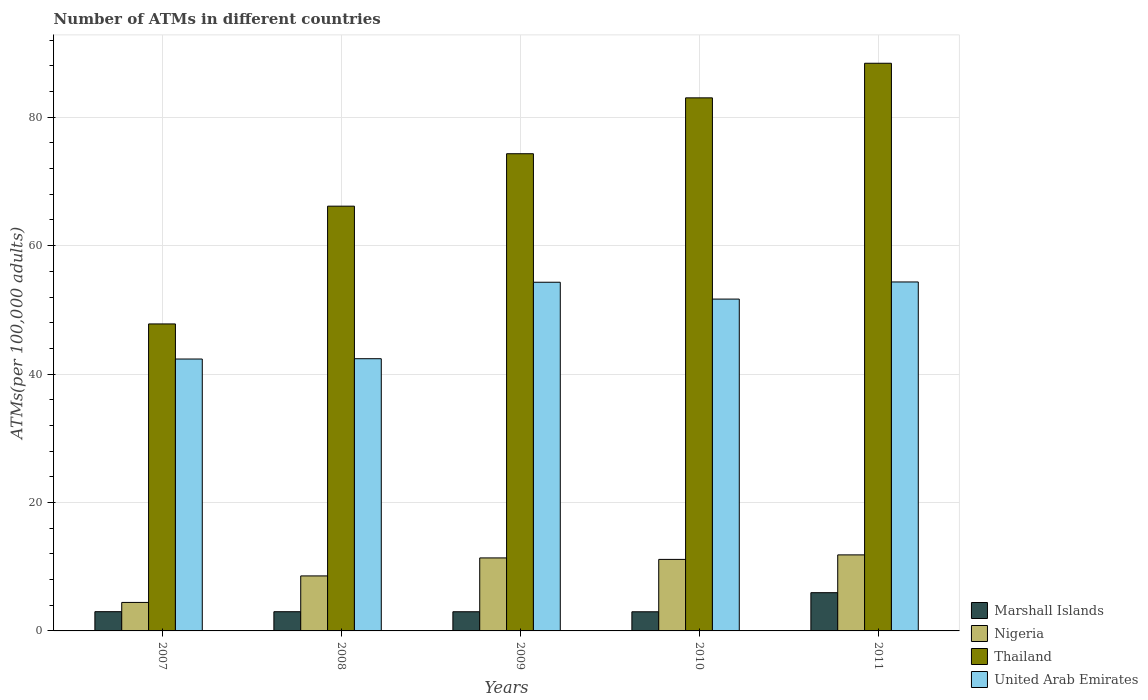How many different coloured bars are there?
Make the answer very short. 4. Are the number of bars per tick equal to the number of legend labels?
Offer a terse response. Yes. What is the label of the 2nd group of bars from the left?
Ensure brevity in your answer.  2008. What is the number of ATMs in Marshall Islands in 2009?
Offer a very short reply. 2.99. Across all years, what is the maximum number of ATMs in United Arab Emirates?
Your response must be concise. 54.35. Across all years, what is the minimum number of ATMs in Thailand?
Make the answer very short. 47.81. What is the total number of ATMs in Thailand in the graph?
Keep it short and to the point. 359.71. What is the difference between the number of ATMs in United Arab Emirates in 2007 and that in 2009?
Offer a terse response. -11.96. What is the difference between the number of ATMs in Marshall Islands in 2008 and the number of ATMs in Thailand in 2009?
Offer a very short reply. -71.33. What is the average number of ATMs in Nigeria per year?
Make the answer very short. 9.47. In the year 2009, what is the difference between the number of ATMs in Nigeria and number of ATMs in Marshall Islands?
Keep it short and to the point. 8.38. In how many years, is the number of ATMs in Nigeria greater than 40?
Offer a very short reply. 0. What is the ratio of the number of ATMs in Thailand in 2010 to that in 2011?
Your answer should be compact. 0.94. What is the difference between the highest and the second highest number of ATMs in Thailand?
Give a very brief answer. 5.39. What is the difference between the highest and the lowest number of ATMs in United Arab Emirates?
Make the answer very short. 12. Is it the case that in every year, the sum of the number of ATMs in Marshall Islands and number of ATMs in Nigeria is greater than the sum of number of ATMs in United Arab Emirates and number of ATMs in Thailand?
Keep it short and to the point. Yes. What does the 1st bar from the left in 2008 represents?
Your answer should be very brief. Marshall Islands. What does the 4th bar from the right in 2007 represents?
Your answer should be compact. Marshall Islands. How many bars are there?
Make the answer very short. 20. How many years are there in the graph?
Make the answer very short. 5. What is the difference between two consecutive major ticks on the Y-axis?
Provide a short and direct response. 20. Are the values on the major ticks of Y-axis written in scientific E-notation?
Ensure brevity in your answer.  No. Does the graph contain any zero values?
Offer a very short reply. No. How many legend labels are there?
Provide a succinct answer. 4. How are the legend labels stacked?
Your response must be concise. Vertical. What is the title of the graph?
Give a very brief answer. Number of ATMs in different countries. Does "Bermuda" appear as one of the legend labels in the graph?
Offer a terse response. No. What is the label or title of the Y-axis?
Provide a succinct answer. ATMs(per 100,0 adults). What is the ATMs(per 100,000 adults) in Marshall Islands in 2007?
Offer a terse response. 3. What is the ATMs(per 100,000 adults) in Nigeria in 2007?
Provide a short and direct response. 4.44. What is the ATMs(per 100,000 adults) of Thailand in 2007?
Your answer should be very brief. 47.81. What is the ATMs(per 100,000 adults) in United Arab Emirates in 2007?
Ensure brevity in your answer.  42.34. What is the ATMs(per 100,000 adults) of Marshall Islands in 2008?
Give a very brief answer. 2.99. What is the ATMs(per 100,000 adults) in Nigeria in 2008?
Your answer should be compact. 8.57. What is the ATMs(per 100,000 adults) in Thailand in 2008?
Your answer should be very brief. 66.15. What is the ATMs(per 100,000 adults) of United Arab Emirates in 2008?
Make the answer very short. 42.39. What is the ATMs(per 100,000 adults) in Marshall Islands in 2009?
Offer a very short reply. 2.99. What is the ATMs(per 100,000 adults) of Nigeria in 2009?
Your response must be concise. 11.37. What is the ATMs(per 100,000 adults) in Thailand in 2009?
Your response must be concise. 74.32. What is the ATMs(per 100,000 adults) of United Arab Emirates in 2009?
Your answer should be very brief. 54.3. What is the ATMs(per 100,000 adults) in Marshall Islands in 2010?
Your answer should be compact. 2.98. What is the ATMs(per 100,000 adults) in Nigeria in 2010?
Your response must be concise. 11.14. What is the ATMs(per 100,000 adults) of Thailand in 2010?
Your answer should be very brief. 83.02. What is the ATMs(per 100,000 adults) in United Arab Emirates in 2010?
Offer a terse response. 51.68. What is the ATMs(per 100,000 adults) of Marshall Islands in 2011?
Provide a succinct answer. 5.95. What is the ATMs(per 100,000 adults) of Nigeria in 2011?
Keep it short and to the point. 11.84. What is the ATMs(per 100,000 adults) of Thailand in 2011?
Provide a short and direct response. 88.41. What is the ATMs(per 100,000 adults) of United Arab Emirates in 2011?
Your answer should be compact. 54.35. Across all years, what is the maximum ATMs(per 100,000 adults) in Marshall Islands?
Provide a short and direct response. 5.95. Across all years, what is the maximum ATMs(per 100,000 adults) of Nigeria?
Keep it short and to the point. 11.84. Across all years, what is the maximum ATMs(per 100,000 adults) in Thailand?
Offer a very short reply. 88.41. Across all years, what is the maximum ATMs(per 100,000 adults) in United Arab Emirates?
Give a very brief answer. 54.35. Across all years, what is the minimum ATMs(per 100,000 adults) of Marshall Islands?
Offer a terse response. 2.98. Across all years, what is the minimum ATMs(per 100,000 adults) of Nigeria?
Make the answer very short. 4.44. Across all years, what is the minimum ATMs(per 100,000 adults) of Thailand?
Ensure brevity in your answer.  47.81. Across all years, what is the minimum ATMs(per 100,000 adults) in United Arab Emirates?
Ensure brevity in your answer.  42.34. What is the total ATMs(per 100,000 adults) of Marshall Islands in the graph?
Offer a terse response. 17.91. What is the total ATMs(per 100,000 adults) of Nigeria in the graph?
Provide a short and direct response. 47.36. What is the total ATMs(per 100,000 adults) of Thailand in the graph?
Give a very brief answer. 359.71. What is the total ATMs(per 100,000 adults) in United Arab Emirates in the graph?
Your response must be concise. 245.07. What is the difference between the ATMs(per 100,000 adults) in Marshall Islands in 2007 and that in 2008?
Provide a succinct answer. 0.01. What is the difference between the ATMs(per 100,000 adults) in Nigeria in 2007 and that in 2008?
Make the answer very short. -4.13. What is the difference between the ATMs(per 100,000 adults) of Thailand in 2007 and that in 2008?
Keep it short and to the point. -18.34. What is the difference between the ATMs(per 100,000 adults) of United Arab Emirates in 2007 and that in 2008?
Provide a short and direct response. -0.05. What is the difference between the ATMs(per 100,000 adults) in Marshall Islands in 2007 and that in 2009?
Provide a short and direct response. 0.01. What is the difference between the ATMs(per 100,000 adults) in Nigeria in 2007 and that in 2009?
Offer a terse response. -6.93. What is the difference between the ATMs(per 100,000 adults) in Thailand in 2007 and that in 2009?
Make the answer very short. -26.51. What is the difference between the ATMs(per 100,000 adults) of United Arab Emirates in 2007 and that in 2009?
Your answer should be very brief. -11.96. What is the difference between the ATMs(per 100,000 adults) in Marshall Islands in 2007 and that in 2010?
Give a very brief answer. 0.02. What is the difference between the ATMs(per 100,000 adults) of Nigeria in 2007 and that in 2010?
Give a very brief answer. -6.7. What is the difference between the ATMs(per 100,000 adults) of Thailand in 2007 and that in 2010?
Make the answer very short. -35.21. What is the difference between the ATMs(per 100,000 adults) in United Arab Emirates in 2007 and that in 2010?
Your answer should be very brief. -9.34. What is the difference between the ATMs(per 100,000 adults) of Marshall Islands in 2007 and that in 2011?
Make the answer very short. -2.96. What is the difference between the ATMs(per 100,000 adults) of Nigeria in 2007 and that in 2011?
Ensure brevity in your answer.  -7.41. What is the difference between the ATMs(per 100,000 adults) of Thailand in 2007 and that in 2011?
Keep it short and to the point. -40.6. What is the difference between the ATMs(per 100,000 adults) of United Arab Emirates in 2007 and that in 2011?
Your answer should be very brief. -12. What is the difference between the ATMs(per 100,000 adults) in Marshall Islands in 2008 and that in 2009?
Provide a succinct answer. 0.01. What is the difference between the ATMs(per 100,000 adults) of Nigeria in 2008 and that in 2009?
Offer a very short reply. -2.8. What is the difference between the ATMs(per 100,000 adults) of Thailand in 2008 and that in 2009?
Your answer should be compact. -8.17. What is the difference between the ATMs(per 100,000 adults) in United Arab Emirates in 2008 and that in 2009?
Keep it short and to the point. -11.91. What is the difference between the ATMs(per 100,000 adults) of Marshall Islands in 2008 and that in 2010?
Make the answer very short. 0.01. What is the difference between the ATMs(per 100,000 adults) of Nigeria in 2008 and that in 2010?
Ensure brevity in your answer.  -2.57. What is the difference between the ATMs(per 100,000 adults) of Thailand in 2008 and that in 2010?
Make the answer very short. -16.87. What is the difference between the ATMs(per 100,000 adults) of United Arab Emirates in 2008 and that in 2010?
Provide a short and direct response. -9.29. What is the difference between the ATMs(per 100,000 adults) in Marshall Islands in 2008 and that in 2011?
Provide a succinct answer. -2.96. What is the difference between the ATMs(per 100,000 adults) of Nigeria in 2008 and that in 2011?
Your answer should be compact. -3.28. What is the difference between the ATMs(per 100,000 adults) of Thailand in 2008 and that in 2011?
Give a very brief answer. -22.26. What is the difference between the ATMs(per 100,000 adults) of United Arab Emirates in 2008 and that in 2011?
Your response must be concise. -11.95. What is the difference between the ATMs(per 100,000 adults) of Marshall Islands in 2009 and that in 2010?
Make the answer very short. 0.01. What is the difference between the ATMs(per 100,000 adults) of Nigeria in 2009 and that in 2010?
Offer a terse response. 0.23. What is the difference between the ATMs(per 100,000 adults) of Thailand in 2009 and that in 2010?
Your response must be concise. -8.7. What is the difference between the ATMs(per 100,000 adults) of United Arab Emirates in 2009 and that in 2010?
Your answer should be compact. 2.62. What is the difference between the ATMs(per 100,000 adults) of Marshall Islands in 2009 and that in 2011?
Your response must be concise. -2.97. What is the difference between the ATMs(per 100,000 adults) in Nigeria in 2009 and that in 2011?
Your answer should be very brief. -0.47. What is the difference between the ATMs(per 100,000 adults) of Thailand in 2009 and that in 2011?
Provide a short and direct response. -14.09. What is the difference between the ATMs(per 100,000 adults) in United Arab Emirates in 2009 and that in 2011?
Offer a very short reply. -0.04. What is the difference between the ATMs(per 100,000 adults) in Marshall Islands in 2010 and that in 2011?
Your answer should be very brief. -2.97. What is the difference between the ATMs(per 100,000 adults) in Nigeria in 2010 and that in 2011?
Provide a succinct answer. -0.7. What is the difference between the ATMs(per 100,000 adults) in Thailand in 2010 and that in 2011?
Offer a terse response. -5.39. What is the difference between the ATMs(per 100,000 adults) in United Arab Emirates in 2010 and that in 2011?
Your answer should be compact. -2.67. What is the difference between the ATMs(per 100,000 adults) of Marshall Islands in 2007 and the ATMs(per 100,000 adults) of Nigeria in 2008?
Offer a very short reply. -5.57. What is the difference between the ATMs(per 100,000 adults) of Marshall Islands in 2007 and the ATMs(per 100,000 adults) of Thailand in 2008?
Keep it short and to the point. -63.16. What is the difference between the ATMs(per 100,000 adults) in Marshall Islands in 2007 and the ATMs(per 100,000 adults) in United Arab Emirates in 2008?
Keep it short and to the point. -39.4. What is the difference between the ATMs(per 100,000 adults) in Nigeria in 2007 and the ATMs(per 100,000 adults) in Thailand in 2008?
Provide a succinct answer. -61.71. What is the difference between the ATMs(per 100,000 adults) of Nigeria in 2007 and the ATMs(per 100,000 adults) of United Arab Emirates in 2008?
Provide a succinct answer. -37.96. What is the difference between the ATMs(per 100,000 adults) of Thailand in 2007 and the ATMs(per 100,000 adults) of United Arab Emirates in 2008?
Offer a terse response. 5.42. What is the difference between the ATMs(per 100,000 adults) in Marshall Islands in 2007 and the ATMs(per 100,000 adults) in Nigeria in 2009?
Make the answer very short. -8.37. What is the difference between the ATMs(per 100,000 adults) in Marshall Islands in 2007 and the ATMs(per 100,000 adults) in Thailand in 2009?
Your answer should be very brief. -71.32. What is the difference between the ATMs(per 100,000 adults) in Marshall Islands in 2007 and the ATMs(per 100,000 adults) in United Arab Emirates in 2009?
Ensure brevity in your answer.  -51.31. What is the difference between the ATMs(per 100,000 adults) of Nigeria in 2007 and the ATMs(per 100,000 adults) of Thailand in 2009?
Your answer should be compact. -69.88. What is the difference between the ATMs(per 100,000 adults) in Nigeria in 2007 and the ATMs(per 100,000 adults) in United Arab Emirates in 2009?
Make the answer very short. -49.87. What is the difference between the ATMs(per 100,000 adults) of Thailand in 2007 and the ATMs(per 100,000 adults) of United Arab Emirates in 2009?
Keep it short and to the point. -6.49. What is the difference between the ATMs(per 100,000 adults) in Marshall Islands in 2007 and the ATMs(per 100,000 adults) in Nigeria in 2010?
Your answer should be compact. -8.14. What is the difference between the ATMs(per 100,000 adults) of Marshall Islands in 2007 and the ATMs(per 100,000 adults) of Thailand in 2010?
Your response must be concise. -80.02. What is the difference between the ATMs(per 100,000 adults) of Marshall Islands in 2007 and the ATMs(per 100,000 adults) of United Arab Emirates in 2010?
Provide a succinct answer. -48.68. What is the difference between the ATMs(per 100,000 adults) in Nigeria in 2007 and the ATMs(per 100,000 adults) in Thailand in 2010?
Provide a succinct answer. -78.58. What is the difference between the ATMs(per 100,000 adults) of Nigeria in 2007 and the ATMs(per 100,000 adults) of United Arab Emirates in 2010?
Your answer should be very brief. -47.24. What is the difference between the ATMs(per 100,000 adults) of Thailand in 2007 and the ATMs(per 100,000 adults) of United Arab Emirates in 2010?
Your answer should be very brief. -3.87. What is the difference between the ATMs(per 100,000 adults) in Marshall Islands in 2007 and the ATMs(per 100,000 adults) in Nigeria in 2011?
Your answer should be very brief. -8.85. What is the difference between the ATMs(per 100,000 adults) in Marshall Islands in 2007 and the ATMs(per 100,000 adults) in Thailand in 2011?
Provide a short and direct response. -85.41. What is the difference between the ATMs(per 100,000 adults) in Marshall Islands in 2007 and the ATMs(per 100,000 adults) in United Arab Emirates in 2011?
Your answer should be very brief. -51.35. What is the difference between the ATMs(per 100,000 adults) of Nigeria in 2007 and the ATMs(per 100,000 adults) of Thailand in 2011?
Your response must be concise. -83.97. What is the difference between the ATMs(per 100,000 adults) in Nigeria in 2007 and the ATMs(per 100,000 adults) in United Arab Emirates in 2011?
Offer a very short reply. -49.91. What is the difference between the ATMs(per 100,000 adults) of Thailand in 2007 and the ATMs(per 100,000 adults) of United Arab Emirates in 2011?
Ensure brevity in your answer.  -6.54. What is the difference between the ATMs(per 100,000 adults) of Marshall Islands in 2008 and the ATMs(per 100,000 adults) of Nigeria in 2009?
Your answer should be very brief. -8.38. What is the difference between the ATMs(per 100,000 adults) in Marshall Islands in 2008 and the ATMs(per 100,000 adults) in Thailand in 2009?
Offer a very short reply. -71.33. What is the difference between the ATMs(per 100,000 adults) of Marshall Islands in 2008 and the ATMs(per 100,000 adults) of United Arab Emirates in 2009?
Provide a succinct answer. -51.31. What is the difference between the ATMs(per 100,000 adults) in Nigeria in 2008 and the ATMs(per 100,000 adults) in Thailand in 2009?
Give a very brief answer. -65.75. What is the difference between the ATMs(per 100,000 adults) in Nigeria in 2008 and the ATMs(per 100,000 adults) in United Arab Emirates in 2009?
Provide a succinct answer. -45.74. What is the difference between the ATMs(per 100,000 adults) in Thailand in 2008 and the ATMs(per 100,000 adults) in United Arab Emirates in 2009?
Offer a very short reply. 11.85. What is the difference between the ATMs(per 100,000 adults) of Marshall Islands in 2008 and the ATMs(per 100,000 adults) of Nigeria in 2010?
Offer a very short reply. -8.15. What is the difference between the ATMs(per 100,000 adults) in Marshall Islands in 2008 and the ATMs(per 100,000 adults) in Thailand in 2010?
Keep it short and to the point. -80.03. What is the difference between the ATMs(per 100,000 adults) of Marshall Islands in 2008 and the ATMs(per 100,000 adults) of United Arab Emirates in 2010?
Provide a succinct answer. -48.69. What is the difference between the ATMs(per 100,000 adults) of Nigeria in 2008 and the ATMs(per 100,000 adults) of Thailand in 2010?
Your answer should be very brief. -74.45. What is the difference between the ATMs(per 100,000 adults) in Nigeria in 2008 and the ATMs(per 100,000 adults) in United Arab Emirates in 2010?
Give a very brief answer. -43.11. What is the difference between the ATMs(per 100,000 adults) of Thailand in 2008 and the ATMs(per 100,000 adults) of United Arab Emirates in 2010?
Give a very brief answer. 14.47. What is the difference between the ATMs(per 100,000 adults) of Marshall Islands in 2008 and the ATMs(per 100,000 adults) of Nigeria in 2011?
Offer a very short reply. -8.85. What is the difference between the ATMs(per 100,000 adults) in Marshall Islands in 2008 and the ATMs(per 100,000 adults) in Thailand in 2011?
Provide a succinct answer. -85.42. What is the difference between the ATMs(per 100,000 adults) of Marshall Islands in 2008 and the ATMs(per 100,000 adults) of United Arab Emirates in 2011?
Your response must be concise. -51.36. What is the difference between the ATMs(per 100,000 adults) in Nigeria in 2008 and the ATMs(per 100,000 adults) in Thailand in 2011?
Your answer should be very brief. -79.84. What is the difference between the ATMs(per 100,000 adults) of Nigeria in 2008 and the ATMs(per 100,000 adults) of United Arab Emirates in 2011?
Your answer should be very brief. -45.78. What is the difference between the ATMs(per 100,000 adults) in Thailand in 2008 and the ATMs(per 100,000 adults) in United Arab Emirates in 2011?
Your answer should be very brief. 11.8. What is the difference between the ATMs(per 100,000 adults) of Marshall Islands in 2009 and the ATMs(per 100,000 adults) of Nigeria in 2010?
Offer a very short reply. -8.15. What is the difference between the ATMs(per 100,000 adults) of Marshall Islands in 2009 and the ATMs(per 100,000 adults) of Thailand in 2010?
Ensure brevity in your answer.  -80.03. What is the difference between the ATMs(per 100,000 adults) of Marshall Islands in 2009 and the ATMs(per 100,000 adults) of United Arab Emirates in 2010?
Offer a very short reply. -48.69. What is the difference between the ATMs(per 100,000 adults) in Nigeria in 2009 and the ATMs(per 100,000 adults) in Thailand in 2010?
Your response must be concise. -71.65. What is the difference between the ATMs(per 100,000 adults) of Nigeria in 2009 and the ATMs(per 100,000 adults) of United Arab Emirates in 2010?
Provide a succinct answer. -40.31. What is the difference between the ATMs(per 100,000 adults) in Thailand in 2009 and the ATMs(per 100,000 adults) in United Arab Emirates in 2010?
Keep it short and to the point. 22.64. What is the difference between the ATMs(per 100,000 adults) in Marshall Islands in 2009 and the ATMs(per 100,000 adults) in Nigeria in 2011?
Ensure brevity in your answer.  -8.86. What is the difference between the ATMs(per 100,000 adults) of Marshall Islands in 2009 and the ATMs(per 100,000 adults) of Thailand in 2011?
Provide a short and direct response. -85.42. What is the difference between the ATMs(per 100,000 adults) of Marshall Islands in 2009 and the ATMs(per 100,000 adults) of United Arab Emirates in 2011?
Give a very brief answer. -51.36. What is the difference between the ATMs(per 100,000 adults) in Nigeria in 2009 and the ATMs(per 100,000 adults) in Thailand in 2011?
Your response must be concise. -77.04. What is the difference between the ATMs(per 100,000 adults) of Nigeria in 2009 and the ATMs(per 100,000 adults) of United Arab Emirates in 2011?
Offer a terse response. -42.98. What is the difference between the ATMs(per 100,000 adults) in Thailand in 2009 and the ATMs(per 100,000 adults) in United Arab Emirates in 2011?
Offer a terse response. 19.97. What is the difference between the ATMs(per 100,000 adults) of Marshall Islands in 2010 and the ATMs(per 100,000 adults) of Nigeria in 2011?
Ensure brevity in your answer.  -8.86. What is the difference between the ATMs(per 100,000 adults) of Marshall Islands in 2010 and the ATMs(per 100,000 adults) of Thailand in 2011?
Your answer should be very brief. -85.43. What is the difference between the ATMs(per 100,000 adults) of Marshall Islands in 2010 and the ATMs(per 100,000 adults) of United Arab Emirates in 2011?
Provide a short and direct response. -51.37. What is the difference between the ATMs(per 100,000 adults) in Nigeria in 2010 and the ATMs(per 100,000 adults) in Thailand in 2011?
Give a very brief answer. -77.27. What is the difference between the ATMs(per 100,000 adults) in Nigeria in 2010 and the ATMs(per 100,000 adults) in United Arab Emirates in 2011?
Provide a succinct answer. -43.21. What is the difference between the ATMs(per 100,000 adults) of Thailand in 2010 and the ATMs(per 100,000 adults) of United Arab Emirates in 2011?
Your answer should be compact. 28.67. What is the average ATMs(per 100,000 adults) of Marshall Islands per year?
Offer a terse response. 3.58. What is the average ATMs(per 100,000 adults) of Nigeria per year?
Your answer should be compact. 9.47. What is the average ATMs(per 100,000 adults) in Thailand per year?
Provide a succinct answer. 71.94. What is the average ATMs(per 100,000 adults) in United Arab Emirates per year?
Your answer should be very brief. 49.01. In the year 2007, what is the difference between the ATMs(per 100,000 adults) of Marshall Islands and ATMs(per 100,000 adults) of Nigeria?
Make the answer very short. -1.44. In the year 2007, what is the difference between the ATMs(per 100,000 adults) in Marshall Islands and ATMs(per 100,000 adults) in Thailand?
Offer a very short reply. -44.81. In the year 2007, what is the difference between the ATMs(per 100,000 adults) in Marshall Islands and ATMs(per 100,000 adults) in United Arab Emirates?
Make the answer very short. -39.35. In the year 2007, what is the difference between the ATMs(per 100,000 adults) in Nigeria and ATMs(per 100,000 adults) in Thailand?
Give a very brief answer. -43.37. In the year 2007, what is the difference between the ATMs(per 100,000 adults) in Nigeria and ATMs(per 100,000 adults) in United Arab Emirates?
Make the answer very short. -37.91. In the year 2007, what is the difference between the ATMs(per 100,000 adults) of Thailand and ATMs(per 100,000 adults) of United Arab Emirates?
Give a very brief answer. 5.47. In the year 2008, what is the difference between the ATMs(per 100,000 adults) of Marshall Islands and ATMs(per 100,000 adults) of Nigeria?
Your answer should be very brief. -5.58. In the year 2008, what is the difference between the ATMs(per 100,000 adults) of Marshall Islands and ATMs(per 100,000 adults) of Thailand?
Offer a terse response. -63.16. In the year 2008, what is the difference between the ATMs(per 100,000 adults) in Marshall Islands and ATMs(per 100,000 adults) in United Arab Emirates?
Give a very brief answer. -39.4. In the year 2008, what is the difference between the ATMs(per 100,000 adults) in Nigeria and ATMs(per 100,000 adults) in Thailand?
Offer a very short reply. -57.59. In the year 2008, what is the difference between the ATMs(per 100,000 adults) in Nigeria and ATMs(per 100,000 adults) in United Arab Emirates?
Provide a succinct answer. -33.83. In the year 2008, what is the difference between the ATMs(per 100,000 adults) in Thailand and ATMs(per 100,000 adults) in United Arab Emirates?
Provide a short and direct response. 23.76. In the year 2009, what is the difference between the ATMs(per 100,000 adults) of Marshall Islands and ATMs(per 100,000 adults) of Nigeria?
Provide a succinct answer. -8.38. In the year 2009, what is the difference between the ATMs(per 100,000 adults) in Marshall Islands and ATMs(per 100,000 adults) in Thailand?
Ensure brevity in your answer.  -71.33. In the year 2009, what is the difference between the ATMs(per 100,000 adults) of Marshall Islands and ATMs(per 100,000 adults) of United Arab Emirates?
Provide a succinct answer. -51.32. In the year 2009, what is the difference between the ATMs(per 100,000 adults) in Nigeria and ATMs(per 100,000 adults) in Thailand?
Your answer should be very brief. -62.95. In the year 2009, what is the difference between the ATMs(per 100,000 adults) in Nigeria and ATMs(per 100,000 adults) in United Arab Emirates?
Keep it short and to the point. -42.93. In the year 2009, what is the difference between the ATMs(per 100,000 adults) in Thailand and ATMs(per 100,000 adults) in United Arab Emirates?
Your answer should be very brief. 20.01. In the year 2010, what is the difference between the ATMs(per 100,000 adults) in Marshall Islands and ATMs(per 100,000 adults) in Nigeria?
Provide a succinct answer. -8.16. In the year 2010, what is the difference between the ATMs(per 100,000 adults) in Marshall Islands and ATMs(per 100,000 adults) in Thailand?
Provide a short and direct response. -80.04. In the year 2010, what is the difference between the ATMs(per 100,000 adults) of Marshall Islands and ATMs(per 100,000 adults) of United Arab Emirates?
Keep it short and to the point. -48.7. In the year 2010, what is the difference between the ATMs(per 100,000 adults) of Nigeria and ATMs(per 100,000 adults) of Thailand?
Offer a very short reply. -71.88. In the year 2010, what is the difference between the ATMs(per 100,000 adults) in Nigeria and ATMs(per 100,000 adults) in United Arab Emirates?
Ensure brevity in your answer.  -40.54. In the year 2010, what is the difference between the ATMs(per 100,000 adults) of Thailand and ATMs(per 100,000 adults) of United Arab Emirates?
Make the answer very short. 31.34. In the year 2011, what is the difference between the ATMs(per 100,000 adults) in Marshall Islands and ATMs(per 100,000 adults) in Nigeria?
Make the answer very short. -5.89. In the year 2011, what is the difference between the ATMs(per 100,000 adults) of Marshall Islands and ATMs(per 100,000 adults) of Thailand?
Make the answer very short. -82.45. In the year 2011, what is the difference between the ATMs(per 100,000 adults) in Marshall Islands and ATMs(per 100,000 adults) in United Arab Emirates?
Offer a very short reply. -48.39. In the year 2011, what is the difference between the ATMs(per 100,000 adults) of Nigeria and ATMs(per 100,000 adults) of Thailand?
Provide a short and direct response. -76.57. In the year 2011, what is the difference between the ATMs(per 100,000 adults) in Nigeria and ATMs(per 100,000 adults) in United Arab Emirates?
Offer a terse response. -42.5. In the year 2011, what is the difference between the ATMs(per 100,000 adults) in Thailand and ATMs(per 100,000 adults) in United Arab Emirates?
Make the answer very short. 34.06. What is the ratio of the ATMs(per 100,000 adults) of Nigeria in 2007 to that in 2008?
Your answer should be very brief. 0.52. What is the ratio of the ATMs(per 100,000 adults) of Thailand in 2007 to that in 2008?
Offer a terse response. 0.72. What is the ratio of the ATMs(per 100,000 adults) of United Arab Emirates in 2007 to that in 2008?
Keep it short and to the point. 1. What is the ratio of the ATMs(per 100,000 adults) of Nigeria in 2007 to that in 2009?
Provide a short and direct response. 0.39. What is the ratio of the ATMs(per 100,000 adults) of Thailand in 2007 to that in 2009?
Your response must be concise. 0.64. What is the ratio of the ATMs(per 100,000 adults) of United Arab Emirates in 2007 to that in 2009?
Your response must be concise. 0.78. What is the ratio of the ATMs(per 100,000 adults) in Nigeria in 2007 to that in 2010?
Keep it short and to the point. 0.4. What is the ratio of the ATMs(per 100,000 adults) in Thailand in 2007 to that in 2010?
Your answer should be very brief. 0.58. What is the ratio of the ATMs(per 100,000 adults) in United Arab Emirates in 2007 to that in 2010?
Make the answer very short. 0.82. What is the ratio of the ATMs(per 100,000 adults) in Marshall Islands in 2007 to that in 2011?
Your answer should be very brief. 0.5. What is the ratio of the ATMs(per 100,000 adults) in Nigeria in 2007 to that in 2011?
Give a very brief answer. 0.37. What is the ratio of the ATMs(per 100,000 adults) in Thailand in 2007 to that in 2011?
Make the answer very short. 0.54. What is the ratio of the ATMs(per 100,000 adults) in United Arab Emirates in 2007 to that in 2011?
Provide a succinct answer. 0.78. What is the ratio of the ATMs(per 100,000 adults) of Marshall Islands in 2008 to that in 2009?
Ensure brevity in your answer.  1. What is the ratio of the ATMs(per 100,000 adults) of Nigeria in 2008 to that in 2009?
Your response must be concise. 0.75. What is the ratio of the ATMs(per 100,000 adults) of Thailand in 2008 to that in 2009?
Ensure brevity in your answer.  0.89. What is the ratio of the ATMs(per 100,000 adults) in United Arab Emirates in 2008 to that in 2009?
Give a very brief answer. 0.78. What is the ratio of the ATMs(per 100,000 adults) in Nigeria in 2008 to that in 2010?
Ensure brevity in your answer.  0.77. What is the ratio of the ATMs(per 100,000 adults) in Thailand in 2008 to that in 2010?
Keep it short and to the point. 0.8. What is the ratio of the ATMs(per 100,000 adults) of United Arab Emirates in 2008 to that in 2010?
Make the answer very short. 0.82. What is the ratio of the ATMs(per 100,000 adults) of Marshall Islands in 2008 to that in 2011?
Your answer should be very brief. 0.5. What is the ratio of the ATMs(per 100,000 adults) in Nigeria in 2008 to that in 2011?
Your answer should be very brief. 0.72. What is the ratio of the ATMs(per 100,000 adults) in Thailand in 2008 to that in 2011?
Provide a short and direct response. 0.75. What is the ratio of the ATMs(per 100,000 adults) in United Arab Emirates in 2008 to that in 2011?
Give a very brief answer. 0.78. What is the ratio of the ATMs(per 100,000 adults) of Marshall Islands in 2009 to that in 2010?
Offer a very short reply. 1. What is the ratio of the ATMs(per 100,000 adults) in Nigeria in 2009 to that in 2010?
Make the answer very short. 1.02. What is the ratio of the ATMs(per 100,000 adults) in Thailand in 2009 to that in 2010?
Offer a terse response. 0.9. What is the ratio of the ATMs(per 100,000 adults) in United Arab Emirates in 2009 to that in 2010?
Your answer should be very brief. 1.05. What is the ratio of the ATMs(per 100,000 adults) in Marshall Islands in 2009 to that in 2011?
Ensure brevity in your answer.  0.5. What is the ratio of the ATMs(per 100,000 adults) of Nigeria in 2009 to that in 2011?
Provide a succinct answer. 0.96. What is the ratio of the ATMs(per 100,000 adults) of Thailand in 2009 to that in 2011?
Ensure brevity in your answer.  0.84. What is the ratio of the ATMs(per 100,000 adults) of United Arab Emirates in 2009 to that in 2011?
Your response must be concise. 1. What is the ratio of the ATMs(per 100,000 adults) of Marshall Islands in 2010 to that in 2011?
Make the answer very short. 0.5. What is the ratio of the ATMs(per 100,000 adults) in Nigeria in 2010 to that in 2011?
Ensure brevity in your answer.  0.94. What is the ratio of the ATMs(per 100,000 adults) of Thailand in 2010 to that in 2011?
Your answer should be very brief. 0.94. What is the ratio of the ATMs(per 100,000 adults) of United Arab Emirates in 2010 to that in 2011?
Keep it short and to the point. 0.95. What is the difference between the highest and the second highest ATMs(per 100,000 adults) in Marshall Islands?
Make the answer very short. 2.96. What is the difference between the highest and the second highest ATMs(per 100,000 adults) of Nigeria?
Your answer should be compact. 0.47. What is the difference between the highest and the second highest ATMs(per 100,000 adults) in Thailand?
Your answer should be very brief. 5.39. What is the difference between the highest and the second highest ATMs(per 100,000 adults) in United Arab Emirates?
Your answer should be compact. 0.04. What is the difference between the highest and the lowest ATMs(per 100,000 adults) of Marshall Islands?
Provide a succinct answer. 2.97. What is the difference between the highest and the lowest ATMs(per 100,000 adults) of Nigeria?
Offer a terse response. 7.41. What is the difference between the highest and the lowest ATMs(per 100,000 adults) in Thailand?
Provide a short and direct response. 40.6. What is the difference between the highest and the lowest ATMs(per 100,000 adults) in United Arab Emirates?
Provide a short and direct response. 12. 